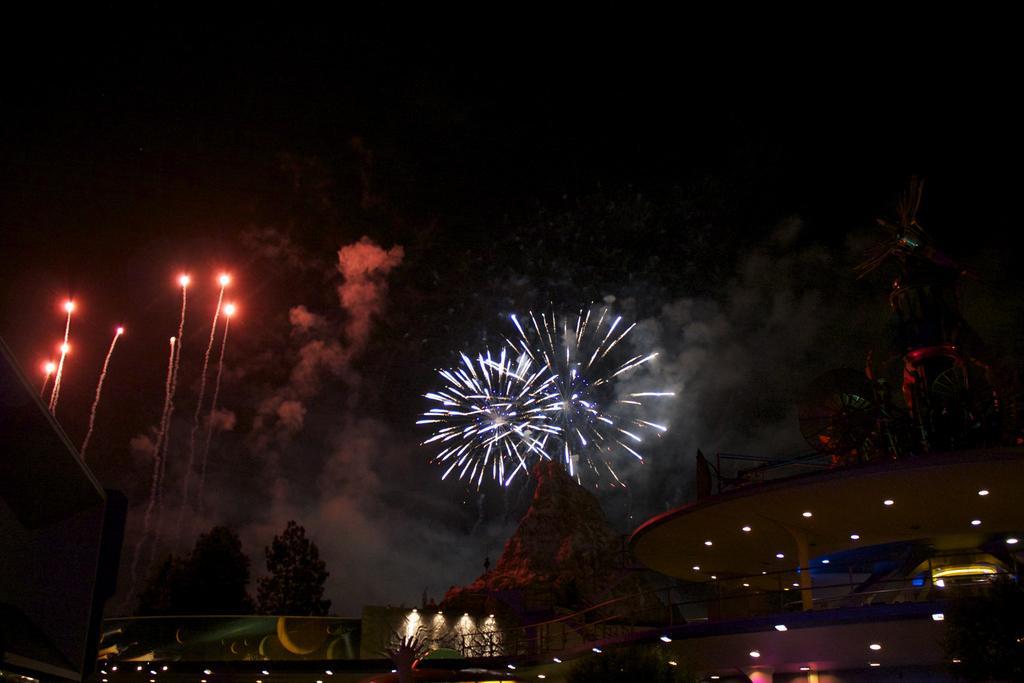Please provide a concise description of this image. In this image there is a building, few lights, firecrackers in the air, trees and a small block. 